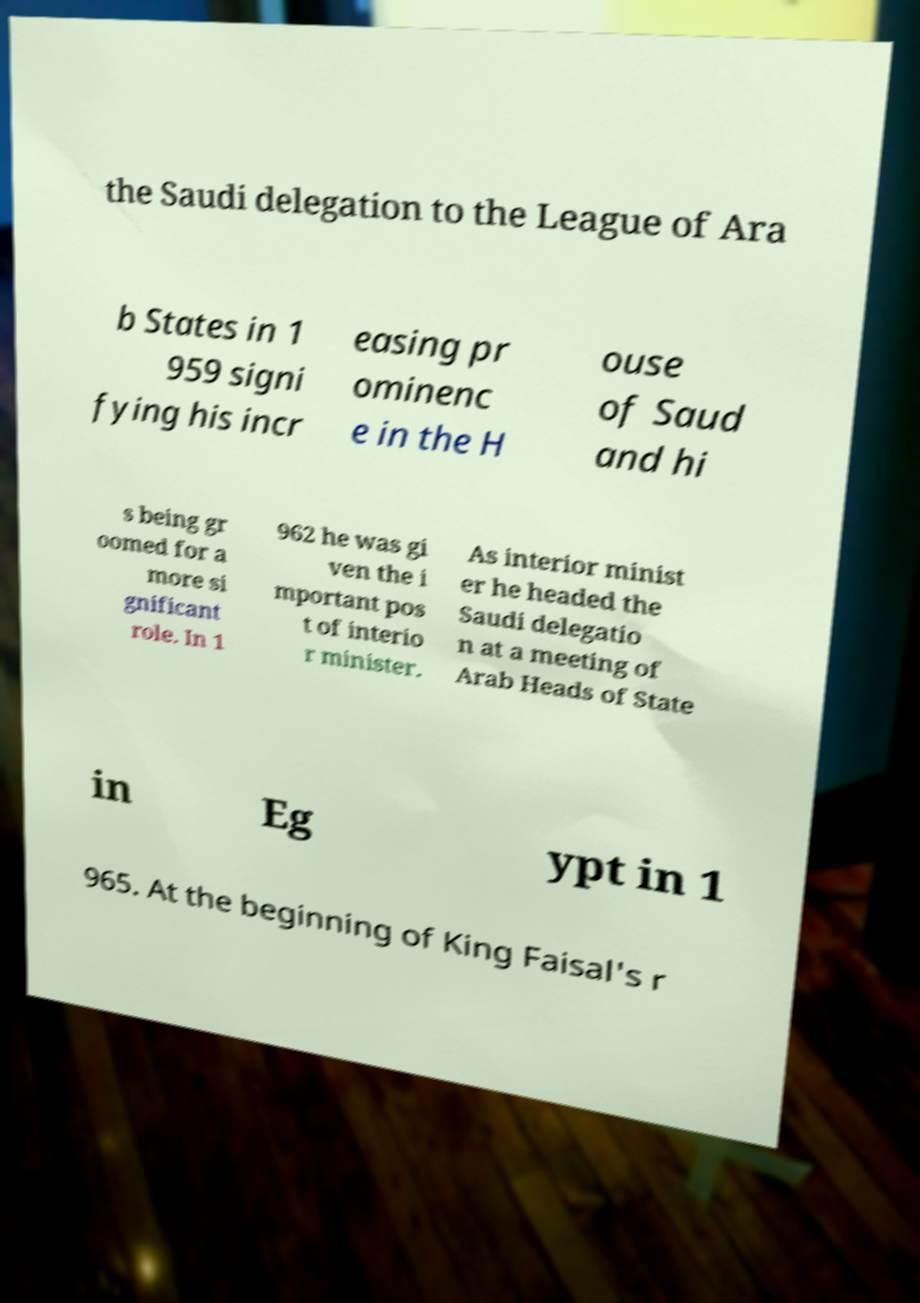Can you read and provide the text displayed in the image?This photo seems to have some interesting text. Can you extract and type it out for me? the Saudi delegation to the League of Ara b States in 1 959 signi fying his incr easing pr ominenc e in the H ouse of Saud and hi s being gr oomed for a more si gnificant role. In 1 962 he was gi ven the i mportant pos t of interio r minister. As interior minist er he headed the Saudi delegatio n at a meeting of Arab Heads of State in Eg ypt in 1 965. At the beginning of King Faisal's r 